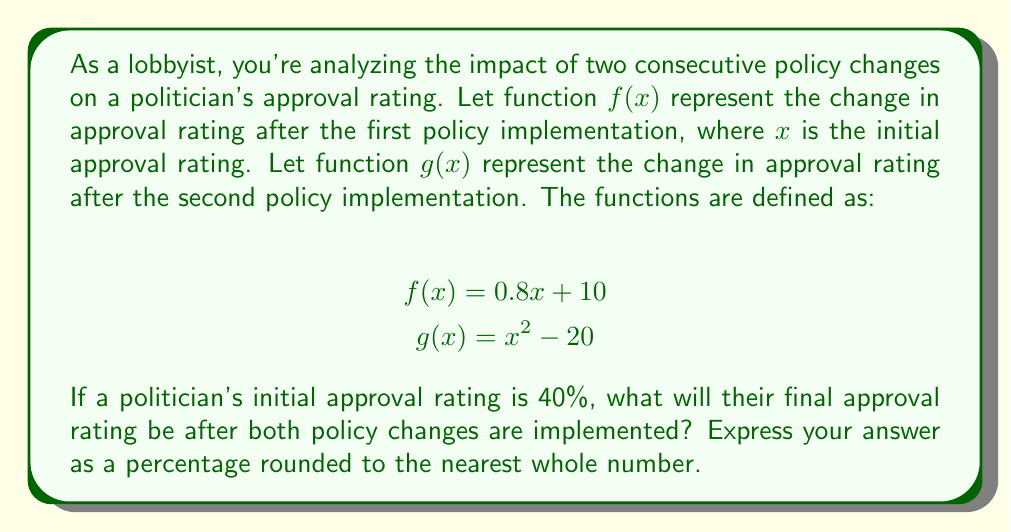Can you solve this math problem? To solve this problem, we need to analyze the composition of functions $g(f(x))$, where $x = 40$ (initial approval rating).

Step 1: Calculate $f(40)$
$$f(40) = 0.8(40) + 10 = 32 + 10 = 42$$

Step 2: Use the result from Step 1 as input for function $g$
$$g(f(40)) = g(42)$$

Step 3: Calculate $g(42)$
$$g(42) = 42^2 - 20 = 1764 - 20 = 1744$$

Step 4: Convert the result to a percentage
$$1744\% = 1744\%$$

Step 5: Round to the nearest whole number
$$1744\% \approx 1744\%$$

The final approval rating after both policy changes is 1744%.
Answer: 1744% 